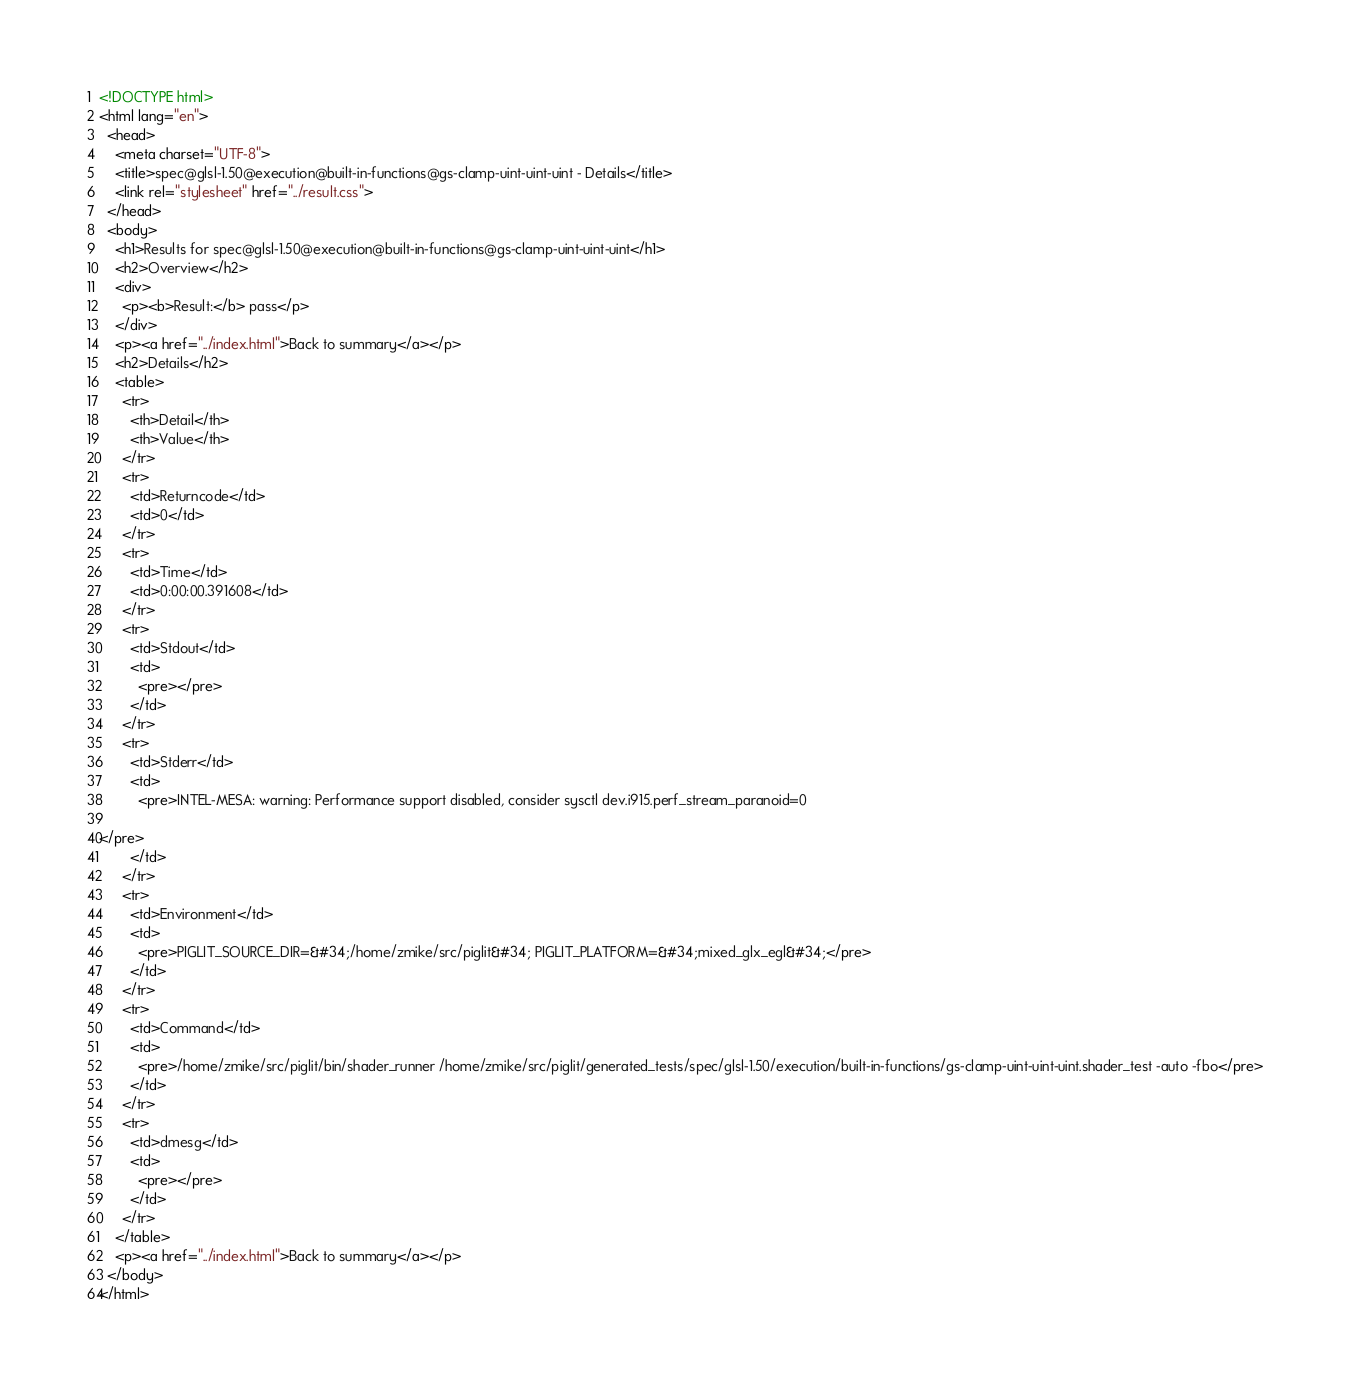<code> <loc_0><loc_0><loc_500><loc_500><_HTML_><!DOCTYPE html>
<html lang="en">
  <head>
    <meta charset="UTF-8">
    <title>spec@glsl-1.50@execution@built-in-functions@gs-clamp-uint-uint-uint - Details</title>
    <link rel="stylesheet" href="../result.css">
  </head>
  <body>
    <h1>Results for spec@glsl-1.50@execution@built-in-functions@gs-clamp-uint-uint-uint</h1>
    <h2>Overview</h2>
    <div>
      <p><b>Result:</b> pass</p>
    </div>
    <p><a href="../index.html">Back to summary</a></p>
    <h2>Details</h2>
    <table>
      <tr>
        <th>Detail</th>
        <th>Value</th>
      </tr>
      <tr>
        <td>Returncode</td>
        <td>0</td>
      </tr>
      <tr>
        <td>Time</td>
        <td>0:00:00.391608</td>
      </tr>
      <tr>
        <td>Stdout</td>
        <td>
          <pre></pre>
        </td>
      </tr>
      <tr>
        <td>Stderr</td>
        <td>
          <pre>INTEL-MESA: warning: Performance support disabled, consider sysctl dev.i915.perf_stream_paranoid=0

</pre>
        </td>
      </tr>
      <tr>
        <td>Environment</td>
        <td>
          <pre>PIGLIT_SOURCE_DIR=&#34;/home/zmike/src/piglit&#34; PIGLIT_PLATFORM=&#34;mixed_glx_egl&#34;</pre>
        </td>
      </tr>
      <tr>
        <td>Command</td>
        <td>
          <pre>/home/zmike/src/piglit/bin/shader_runner /home/zmike/src/piglit/generated_tests/spec/glsl-1.50/execution/built-in-functions/gs-clamp-uint-uint-uint.shader_test -auto -fbo</pre>
        </td>
      </tr>
      <tr>
        <td>dmesg</td>
        <td>
          <pre></pre>
        </td>
      </tr>
    </table>
    <p><a href="../index.html">Back to summary</a></p>
  </body>
</html>
</code> 